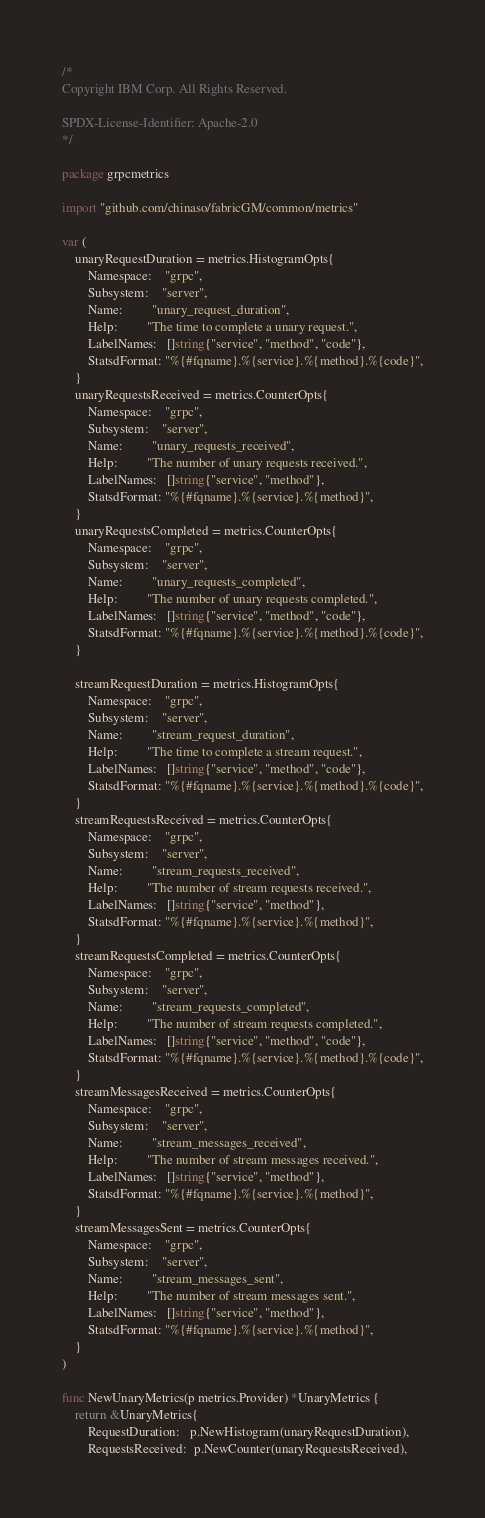<code> <loc_0><loc_0><loc_500><loc_500><_Go_>/*
Copyright IBM Corp. All Rights Reserved.

SPDX-License-Identifier: Apache-2.0
*/

package grpcmetrics

import "github.com/chinaso/fabricGM/common/metrics"

var (
	unaryRequestDuration = metrics.HistogramOpts{
		Namespace:    "grpc",
		Subsystem:    "server",
		Name:         "unary_request_duration",
		Help:         "The time to complete a unary request.",
		LabelNames:   []string{"service", "method", "code"},
		StatsdFormat: "%{#fqname}.%{service}.%{method}.%{code}",
	}
	unaryRequestsReceived = metrics.CounterOpts{
		Namespace:    "grpc",
		Subsystem:    "server",
		Name:         "unary_requests_received",
		Help:         "The number of unary requests received.",
		LabelNames:   []string{"service", "method"},
		StatsdFormat: "%{#fqname}.%{service}.%{method}",
	}
	unaryRequestsCompleted = metrics.CounterOpts{
		Namespace:    "grpc",
		Subsystem:    "server",
		Name:         "unary_requests_completed",
		Help:         "The number of unary requests completed.",
		LabelNames:   []string{"service", "method", "code"},
		StatsdFormat: "%{#fqname}.%{service}.%{method}.%{code}",
	}

	streamRequestDuration = metrics.HistogramOpts{
		Namespace:    "grpc",
		Subsystem:    "server",
		Name:         "stream_request_duration",
		Help:         "The time to complete a stream request.",
		LabelNames:   []string{"service", "method", "code"},
		StatsdFormat: "%{#fqname}.%{service}.%{method}.%{code}",
	}
	streamRequestsReceived = metrics.CounterOpts{
		Namespace:    "grpc",
		Subsystem:    "server",
		Name:         "stream_requests_received",
		Help:         "The number of stream requests received.",
		LabelNames:   []string{"service", "method"},
		StatsdFormat: "%{#fqname}.%{service}.%{method}",
	}
	streamRequestsCompleted = metrics.CounterOpts{
		Namespace:    "grpc",
		Subsystem:    "server",
		Name:         "stream_requests_completed",
		Help:         "The number of stream requests completed.",
		LabelNames:   []string{"service", "method", "code"},
		StatsdFormat: "%{#fqname}.%{service}.%{method}.%{code}",
	}
	streamMessagesReceived = metrics.CounterOpts{
		Namespace:    "grpc",
		Subsystem:    "server",
		Name:         "stream_messages_received",
		Help:         "The number of stream messages received.",
		LabelNames:   []string{"service", "method"},
		StatsdFormat: "%{#fqname}.%{service}.%{method}",
	}
	streamMessagesSent = metrics.CounterOpts{
		Namespace:    "grpc",
		Subsystem:    "server",
		Name:         "stream_messages_sent",
		Help:         "The number of stream messages sent.",
		LabelNames:   []string{"service", "method"},
		StatsdFormat: "%{#fqname}.%{service}.%{method}",
	}
)

func NewUnaryMetrics(p metrics.Provider) *UnaryMetrics {
	return &UnaryMetrics{
		RequestDuration:   p.NewHistogram(unaryRequestDuration),
		RequestsReceived:  p.NewCounter(unaryRequestsReceived),</code> 